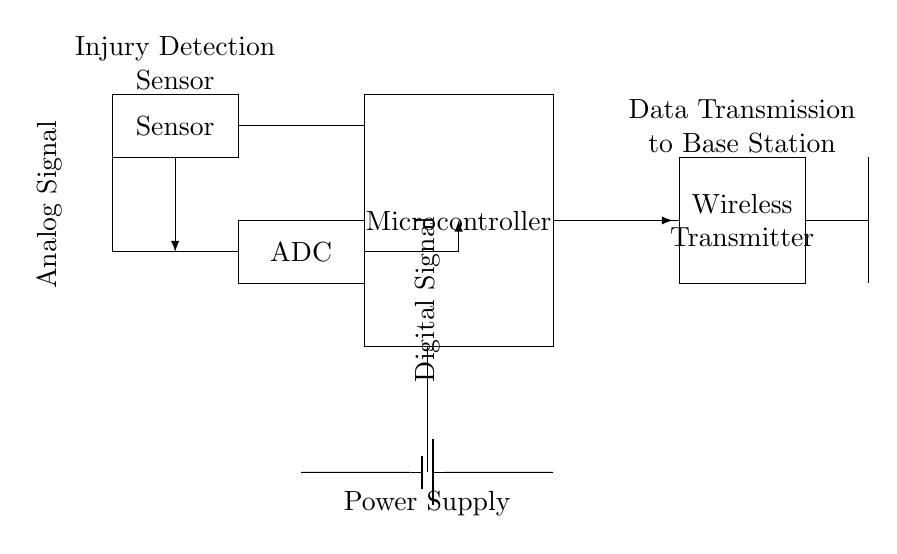What is the primary component responsible for data processing? The microcontroller receives data from the sensor and processes it for transmission.
Answer: Microcontroller What type of signal does the ADC convert? The ADC converts analog signals from the sensor into digital signals for further processing in the microcontroller.
Answer: Analog signal What is the function of the wireless transmitter in the circuit? The wireless transmitter takes the processed digital signal and transmits it wirelessly to a base station for monitoring or analysis.
Answer: Data transmission How is power supplied to the circuit? Power is supplied through a battery connected to the microcontroller and other components, providing the necessary voltage for their operation.
Answer: Battery What comes after the ADC in the circuit flow? After the ADC, the data is sent to the microcontroller for further processing before being transmitted wirelessly.
Answer: Microcontroller What type of component is the antenna? The antenna is a passive component that receives and transmits electromagnetic waves for wireless communication.
Answer: Antenna Which component appears to directly connect to the sensor? The ADC connects directly to the sensor, receiving the analog signals produced by it.
Answer: ADC 